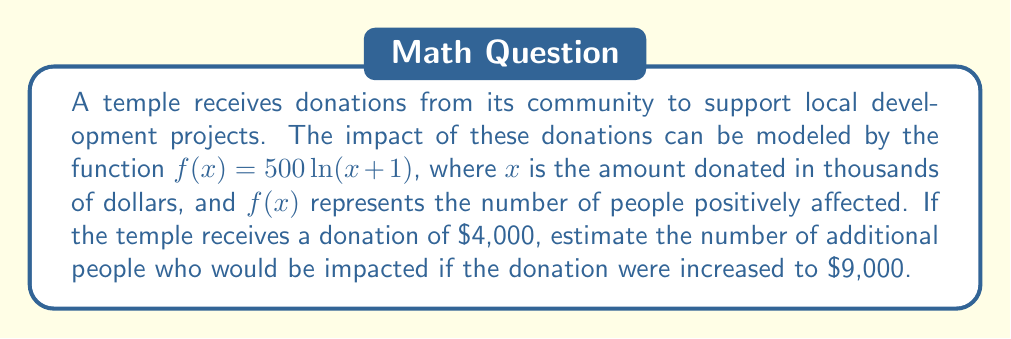Can you solve this math problem? To solve this problem, we need to follow these steps:

1. Calculate the impact of the initial donation of $4,000:
   $x_1 = 4$ (since $x$ is in thousands of dollars)
   $f(x_1) = 500\ln(4+1) = 500\ln(5) \approx 804.72$

2. Calculate the impact of the increased donation of $9,000:
   $x_2 = 9$
   $f(x_2) = 500\ln(9+1) = 500\ln(10) \approx 1151.29$

3. Find the difference between the two impacts:
   Additional impact = $f(x_2) - f(x_1)$
   $= 1151.29 - 804.72 \approx 346.57$

Therefore, the estimated number of additional people impacted by increasing the donation from $4,000 to $9,000 is approximately 347 people (rounded to the nearest whole number).
Answer: 347 people 